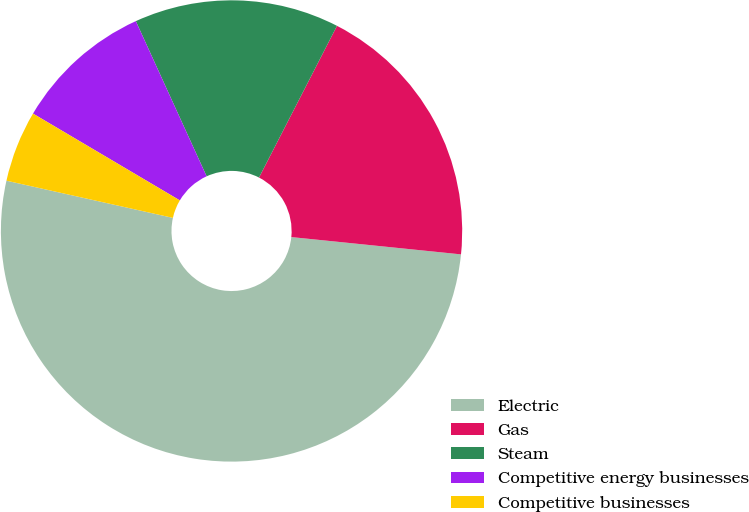Convert chart. <chart><loc_0><loc_0><loc_500><loc_500><pie_chart><fcel>Electric<fcel>Gas<fcel>Steam<fcel>Competitive energy businesses<fcel>Competitive businesses<nl><fcel>51.88%<fcel>19.06%<fcel>14.37%<fcel>9.69%<fcel>5.0%<nl></chart> 